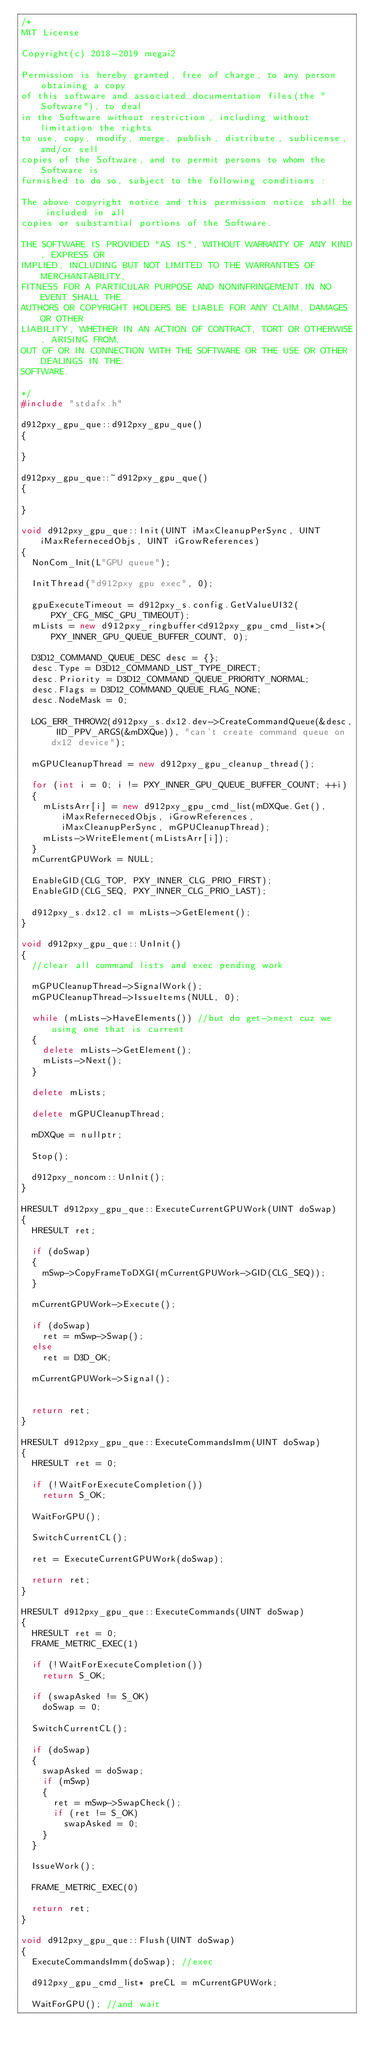<code> <loc_0><loc_0><loc_500><loc_500><_C++_>/*
MIT License

Copyright(c) 2018-2019 megai2

Permission is hereby granted, free of charge, to any person obtaining a copy
of this software and associated documentation files(the "Software"), to deal
in the Software without restriction, including without limitation the rights
to use, copy, modify, merge, publish, distribute, sublicense, and/or sell
copies of the Software, and to permit persons to whom the Software is
furnished to do so, subject to the following conditions :

The above copyright notice and this permission notice shall be included in all
copies or substantial portions of the Software.

THE SOFTWARE IS PROVIDED "AS IS", WITHOUT WARRANTY OF ANY KIND, EXPRESS OR
IMPLIED, INCLUDING BUT NOT LIMITED TO THE WARRANTIES OF MERCHANTABILITY,
FITNESS FOR A PARTICULAR PURPOSE AND NONINFRINGEMENT.IN NO EVENT SHALL THE
AUTHORS OR COPYRIGHT HOLDERS BE LIABLE FOR ANY CLAIM, DAMAGES OR OTHER
LIABILITY, WHETHER IN AN ACTION OF CONTRACT, TORT OR OTHERWISE, ARISING FROM,
OUT OF OR IN CONNECTION WITH THE SOFTWARE OR THE USE OR OTHER DEALINGS IN THE
SOFTWARE.

*/
#include "stdafx.h"

d912pxy_gpu_que::d912pxy_gpu_que() 
{

}

d912pxy_gpu_que::~d912pxy_gpu_que()
{

}

void d912pxy_gpu_que::Init(UINT iMaxCleanupPerSync, UINT iMaxRefernecedObjs, UINT iGrowReferences)
{
	NonCom_Init(L"GPU queue");

	InitThread("d912pxy gpu exec", 0);
	
	gpuExecuteTimeout = d912pxy_s.config.GetValueUI32(PXY_CFG_MISC_GPU_TIMEOUT);
	mLists = new d912pxy_ringbuffer<d912pxy_gpu_cmd_list*>(PXY_INNER_GPU_QUEUE_BUFFER_COUNT, 0);

	D3D12_COMMAND_QUEUE_DESC desc = {};
	desc.Type = D3D12_COMMAND_LIST_TYPE_DIRECT;
	desc.Priority = D3D12_COMMAND_QUEUE_PRIORITY_NORMAL;
	desc.Flags = D3D12_COMMAND_QUEUE_FLAG_NONE;
	desc.NodeMask = 0;

	LOG_ERR_THROW2(d912pxy_s.dx12.dev->CreateCommandQueue(&desc, IID_PPV_ARGS(&mDXQue)), "can't create command queue on dx12 device");

	mGPUCleanupThread = new d912pxy_gpu_cleanup_thread();

	for (int i = 0; i != PXY_INNER_GPU_QUEUE_BUFFER_COUNT; ++i)
	{
		mListsArr[i] = new d912pxy_gpu_cmd_list(mDXQue.Get(), iMaxRefernecedObjs, iGrowReferences, iMaxCleanupPerSync, mGPUCleanupThread);
		mLists->WriteElement(mListsArr[i]);
	}
	mCurrentGPUWork = NULL;

	EnableGID(CLG_TOP, PXY_INNER_CLG_PRIO_FIRST);
	EnableGID(CLG_SEQ, PXY_INNER_CLG_PRIO_LAST);

	d912pxy_s.dx12.cl = mLists->GetElement();
}

void d912pxy_gpu_que::UnInit()
{
	//clear all command lists and exec pending work

	mGPUCleanupThread->SignalWork();
	mGPUCleanupThread->IssueItems(NULL, 0);

	while (mLists->HaveElements()) //but do get->next cuz we using one that is current
	{
		delete mLists->GetElement();
		mLists->Next();
	}

	delete mLists;

	delete mGPUCleanupThread;

	mDXQue = nullptr;

	Stop();

	d912pxy_noncom::UnInit();
}

HRESULT d912pxy_gpu_que::ExecuteCurrentGPUWork(UINT doSwap)
{
	HRESULT ret;

	if (doSwap)
	{
		mSwp->CopyFrameToDXGI(mCurrentGPUWork->GID(CLG_SEQ));
	}

	mCurrentGPUWork->Execute();

	if (doSwap)
		ret = mSwp->Swap();
	else
		ret = D3D_OK;

	mCurrentGPUWork->Signal();
	
		
	return ret;
}

HRESULT d912pxy_gpu_que::ExecuteCommandsImm(UINT doSwap)
{
	HRESULT ret = 0;

	if (!WaitForExecuteCompletion())
		return S_OK;

	WaitForGPU();

	SwitchCurrentCL();

	ret = ExecuteCurrentGPUWork(doSwap);

	return ret;
}

HRESULT d912pxy_gpu_que::ExecuteCommands(UINT doSwap)
{
	HRESULT ret = 0;
	FRAME_METRIC_EXEC(1)

	if (!WaitForExecuteCompletion())
		return S_OK;
	
	if (swapAsked != S_OK)	
		doSwap = 0;	

	SwitchCurrentCL();

	if (doSwap)
	{
		swapAsked = doSwap;
		if (mSwp)
		{
			ret = mSwp->SwapCheck();
			if (ret != S_OK)
				swapAsked = 0;
		}
	}
		
	IssueWork();

	FRAME_METRIC_EXEC(0)

	return ret;
}

void d912pxy_gpu_que::Flush(UINT doSwap)
{		
	ExecuteCommandsImm(doSwap); //exec 

	d912pxy_gpu_cmd_list* preCL = mCurrentGPUWork;

	WaitForGPU(); //and wait
</code> 